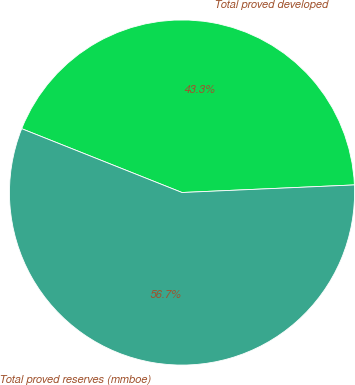Convert chart. <chart><loc_0><loc_0><loc_500><loc_500><pie_chart><fcel>Total proved developed<fcel>Total proved reserves (mmboe)<nl><fcel>43.27%<fcel>56.73%<nl></chart> 